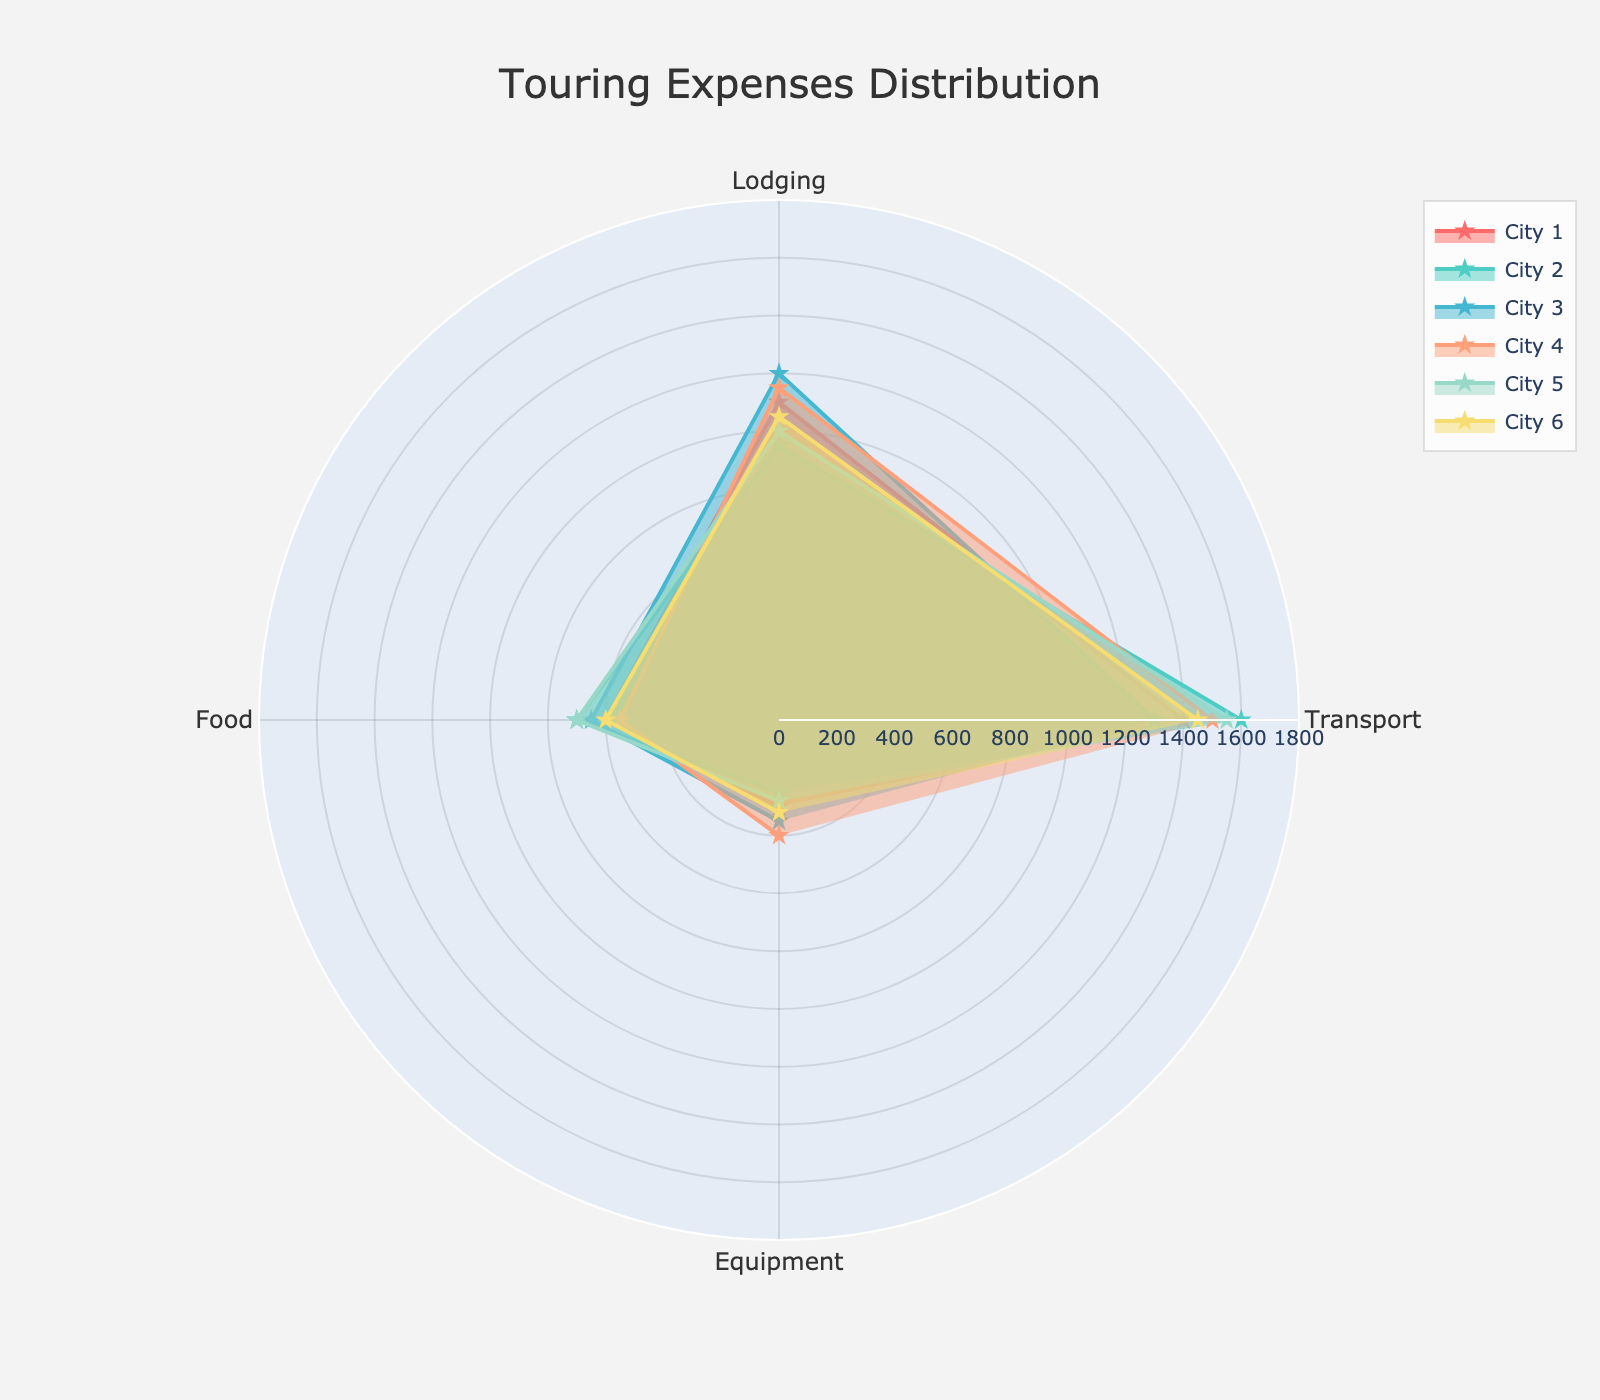What is the title of the figure? The title is usually found at the top of the figure. It summarizes what the figure is about.
Answer: Touring Expenses Distribution Which city has the highest transportation expense? Look for the data point representing the transportation expense, which is the first category, on the radar chart for each city. Compare the values visually.
Answer: City 2 What is the average lodging expense across all cities? Calculate the average of lodging expenses for all cities: (1100 + 950 + 1200 + 1150 + 1000 + 1050) / 6 = 1083.33
Answer: 1083.33 Which city spends the least on equipment maintenance? Identify the data points or sectors representing equipment maintenance on the radar chart and compare the values for each city.
Answer: City 2 Compare the food expenses of City 1 and City 3. Which city spends more and by how much? Locate the food expense data points for City 1 and City 3 and subtract the smaller value from the larger value: 650 - 600 = 50. City 3 spends more by 50.
Answer: City 3, 50 How does the lodging expense of City 4 compare to its food expense? Find the data points for lodging and food expenses for City 4 and compare them: lodging is 1150 while food is 550. Lodging is higher.
Answer: Lodging is higher What is the total expense for City 5? Sum all the category values for City 5: 1550 (Transport) + 1000 (Lodging) + 700 (Food) + 280 (Equipment) = 3530.
Answer: 3530 Which city has the most balanced distribution of expenses across all categories? Identify the city whose radar chart sectors are the most evenly distributed without extreme values in any category.
Answer: City 6 If transport expenses are increased by 10% for all cities, what would be the new transport expense for City 1? Calculate a 10% increase for City 1's transport expense: 1400 * 1.10 = 1540.
Answer: 1540 Which categories show a consistent expense pattern across most cities? Compare the radar chart segments for each category across cities. Look for categories where the visual data points are closely aligned.
Answer: Food and Lodging 